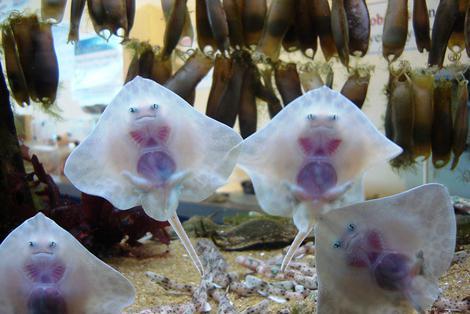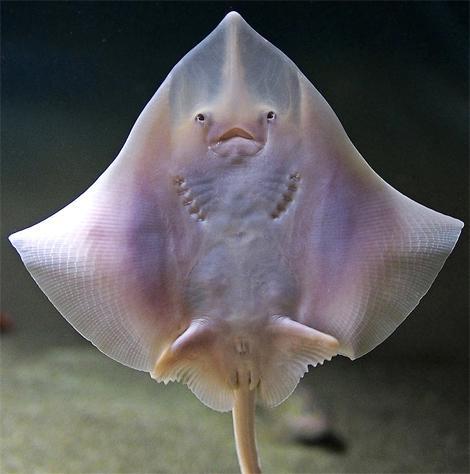The first image is the image on the left, the second image is the image on the right. For the images shown, is this caption "The left and right image contains a total of five stingrays." true? Answer yes or no. Yes. The first image is the image on the left, the second image is the image on the right. Given the left and right images, does the statement "The left image contains just one stingray." hold true? Answer yes or no. No. 